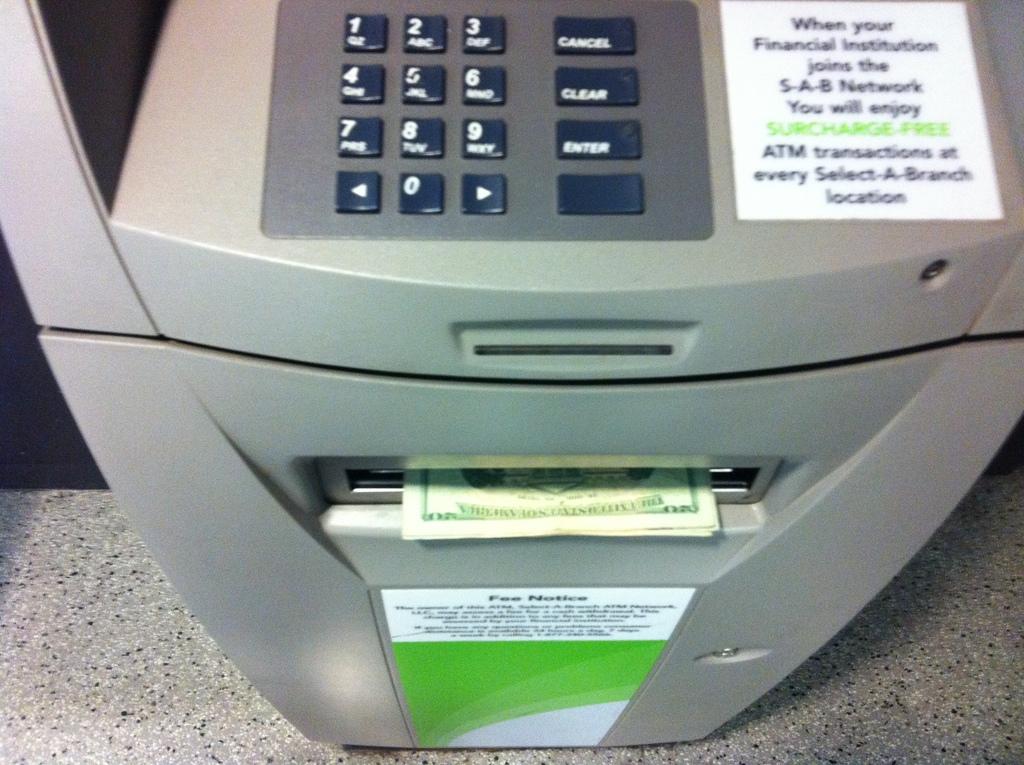This is atm machine?
Ensure brevity in your answer.  Yes. 